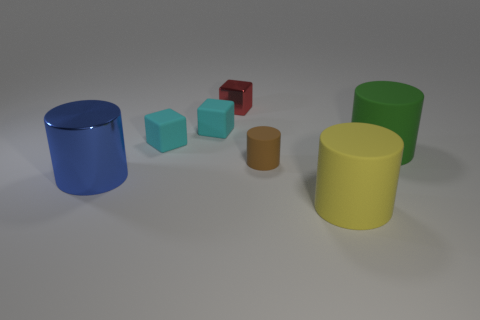Add 1 tiny red cubes. How many objects exist? 8 Subtract all blocks. How many objects are left? 4 Add 6 red cubes. How many red cubes are left? 7 Add 5 red rubber balls. How many red rubber balls exist? 5 Subtract 0 green blocks. How many objects are left? 7 Subtract all cyan matte cubes. Subtract all yellow things. How many objects are left? 4 